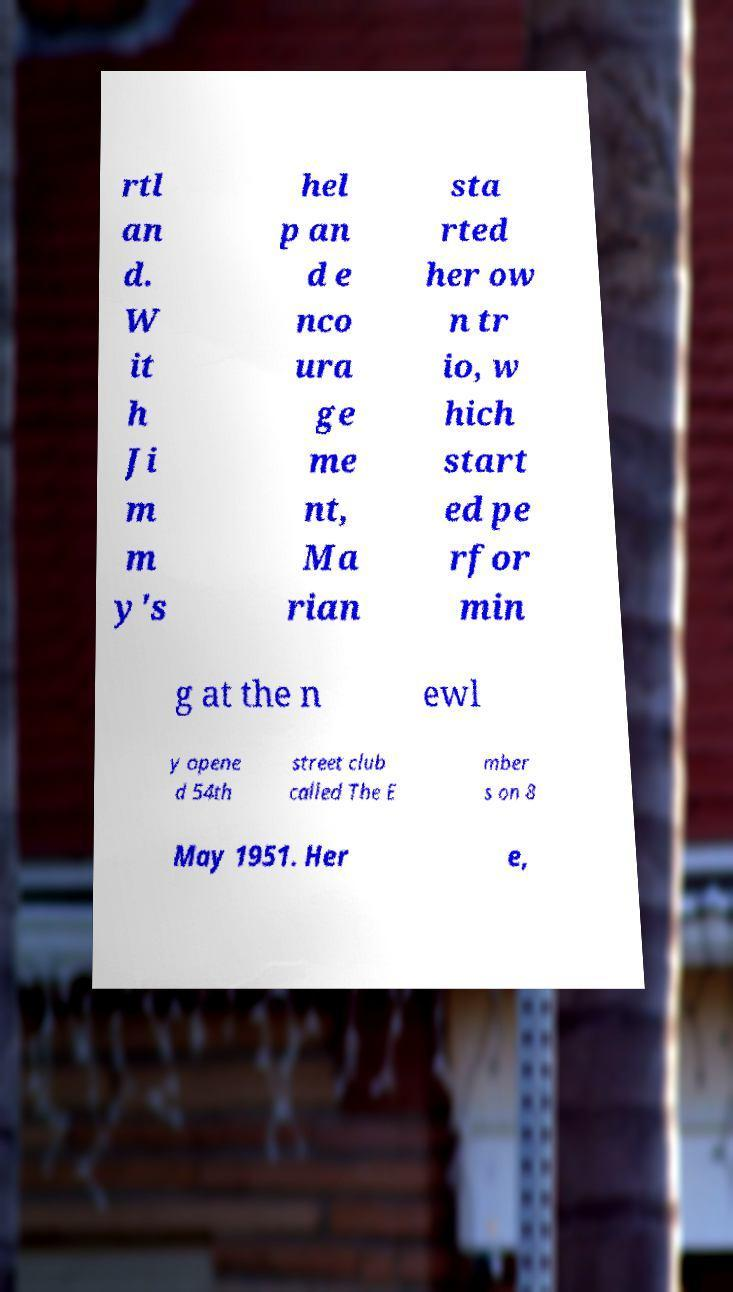There's text embedded in this image that I need extracted. Can you transcribe it verbatim? rtl an d. W it h Ji m m y's hel p an d e nco ura ge me nt, Ma rian sta rted her ow n tr io, w hich start ed pe rfor min g at the n ewl y opene d 54th street club called The E mber s on 8 May 1951. Her e, 